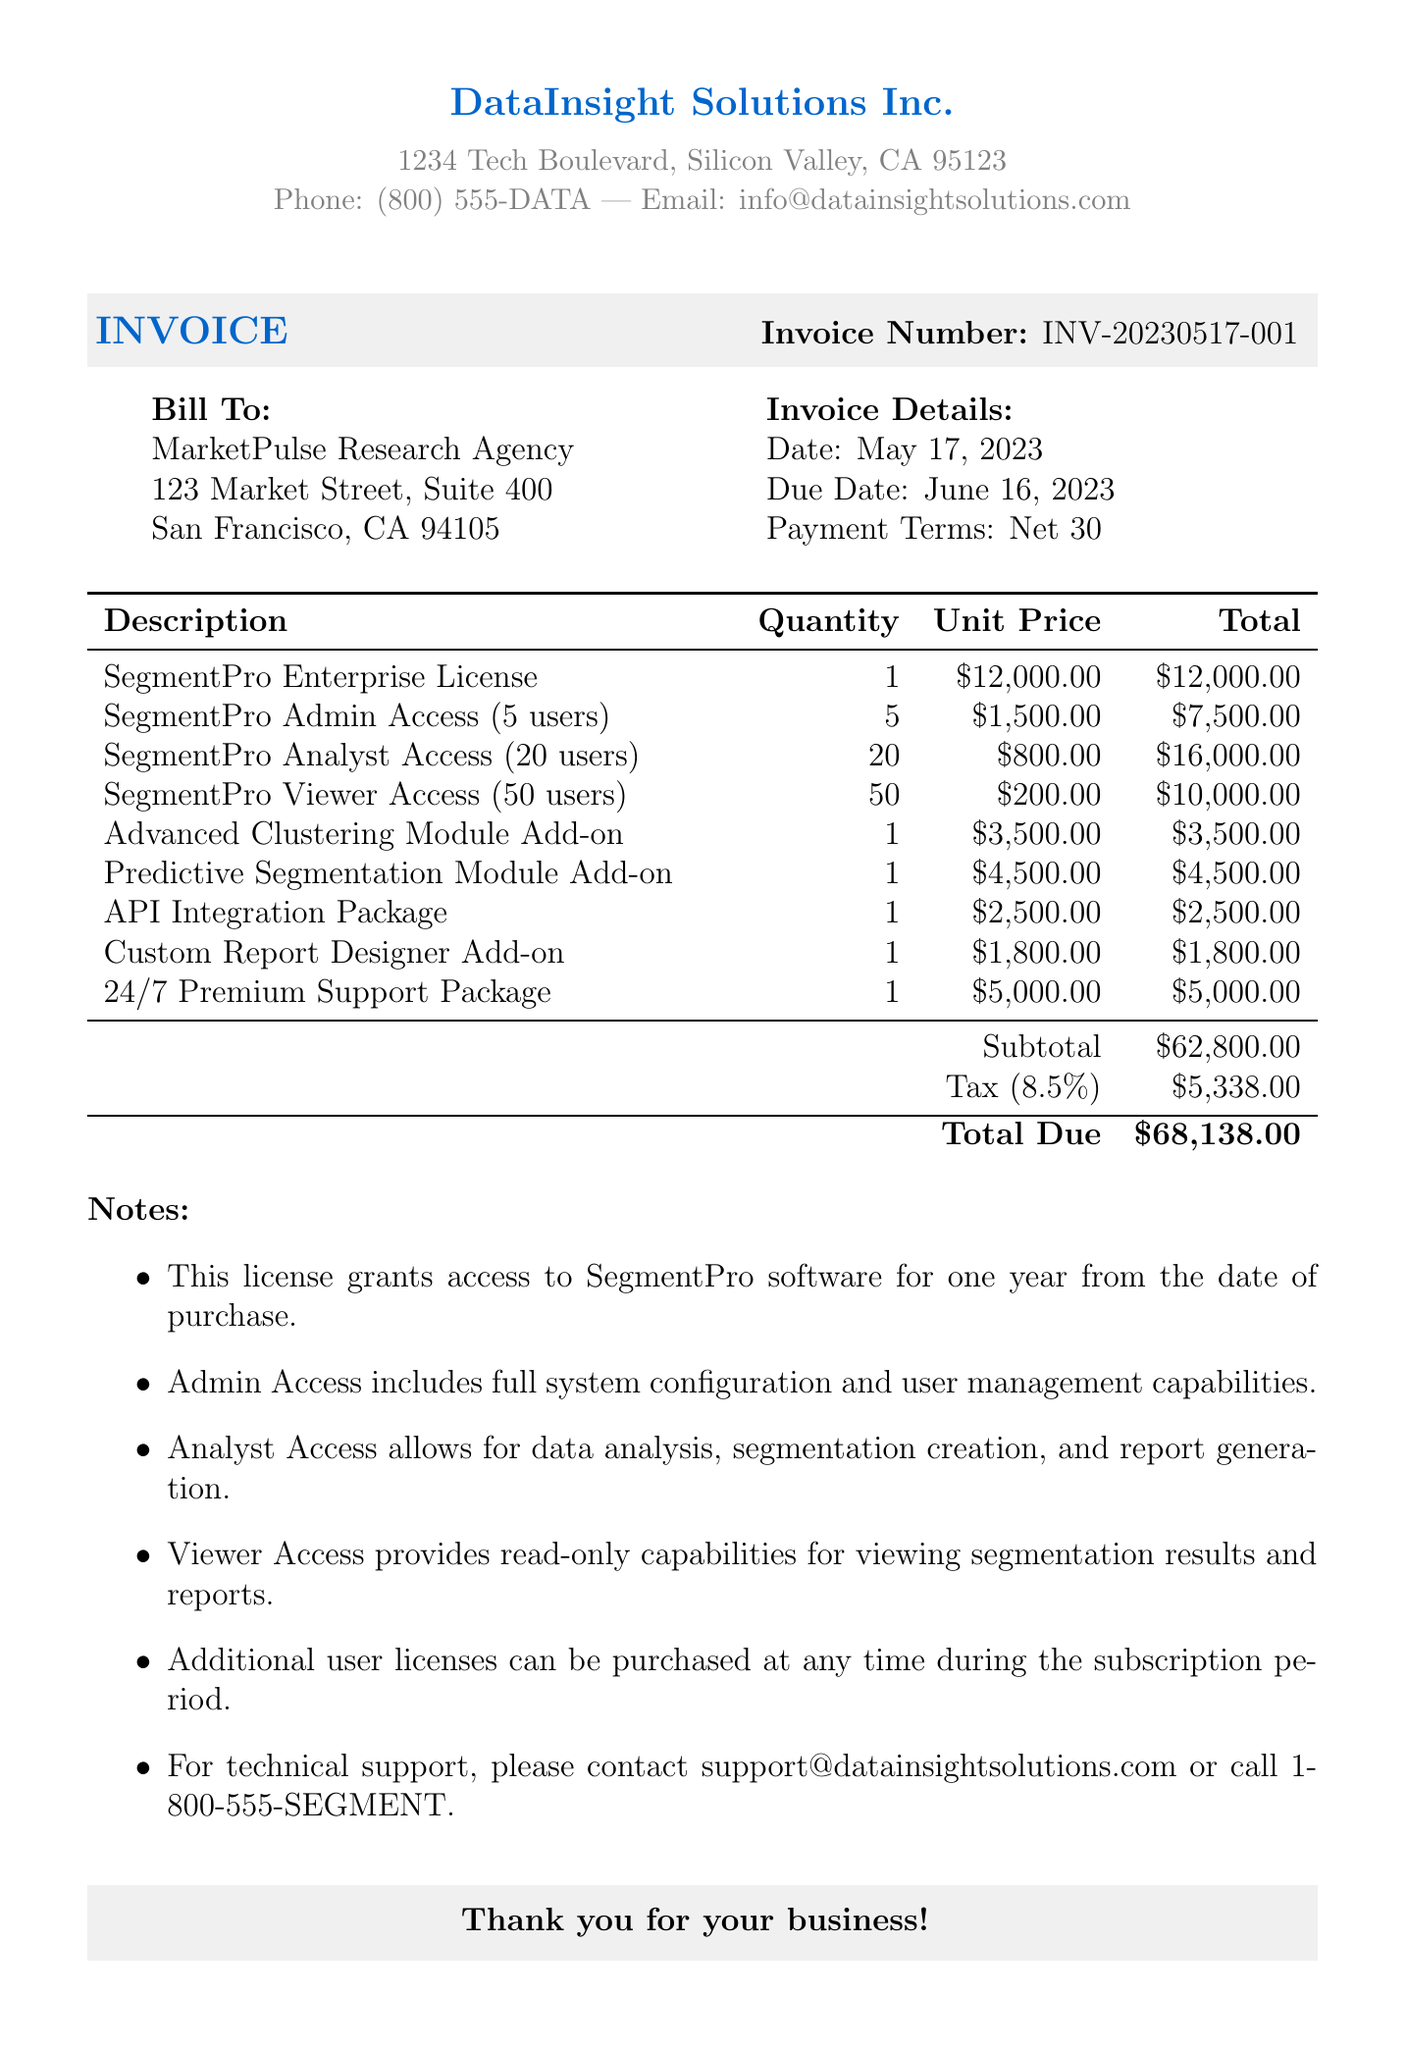What is the invoice number? The invoice number is a unique identifier for the billing statement, located near the top of the document.
Answer: INV-20230517-001 What is the date of the invoice? The date of the invoice is specified on the document, indicating when it was issued.
Answer: May 17, 2023 How many users have Admin Access? The document specifies the number of users for each access level under the itemized list.
Answer: 5 users What is the total amount due? The total amount due is provided at the bottom of the itemized list as the final calculation with tax included.
Answer: $68,138.00 What is the tax rate applied? The tax rate is indicated in the document as a percentage used to calculate the tax amount.
Answer: 8.5% How much does the SegmentPro Enterprise License cost? The itemized pricing section reveals the unit price for each license type.
Answer: $12,000.00 What is included in the Analyst Access? The document provides a brief description of what features come with each user access level.
Answer: Data analysis, segmentation creation, and report generation What is the payment term stated in the invoice? The payment terms are specified in the document, indicating when payment is expected.
Answer: Net 30 What is the address for MarketPulse Research Agency? The billing address is clearly listed under the "Bill To" section of the document.
Answer: 123 Market Street, Suite 400, San Francisco, CA 94105 